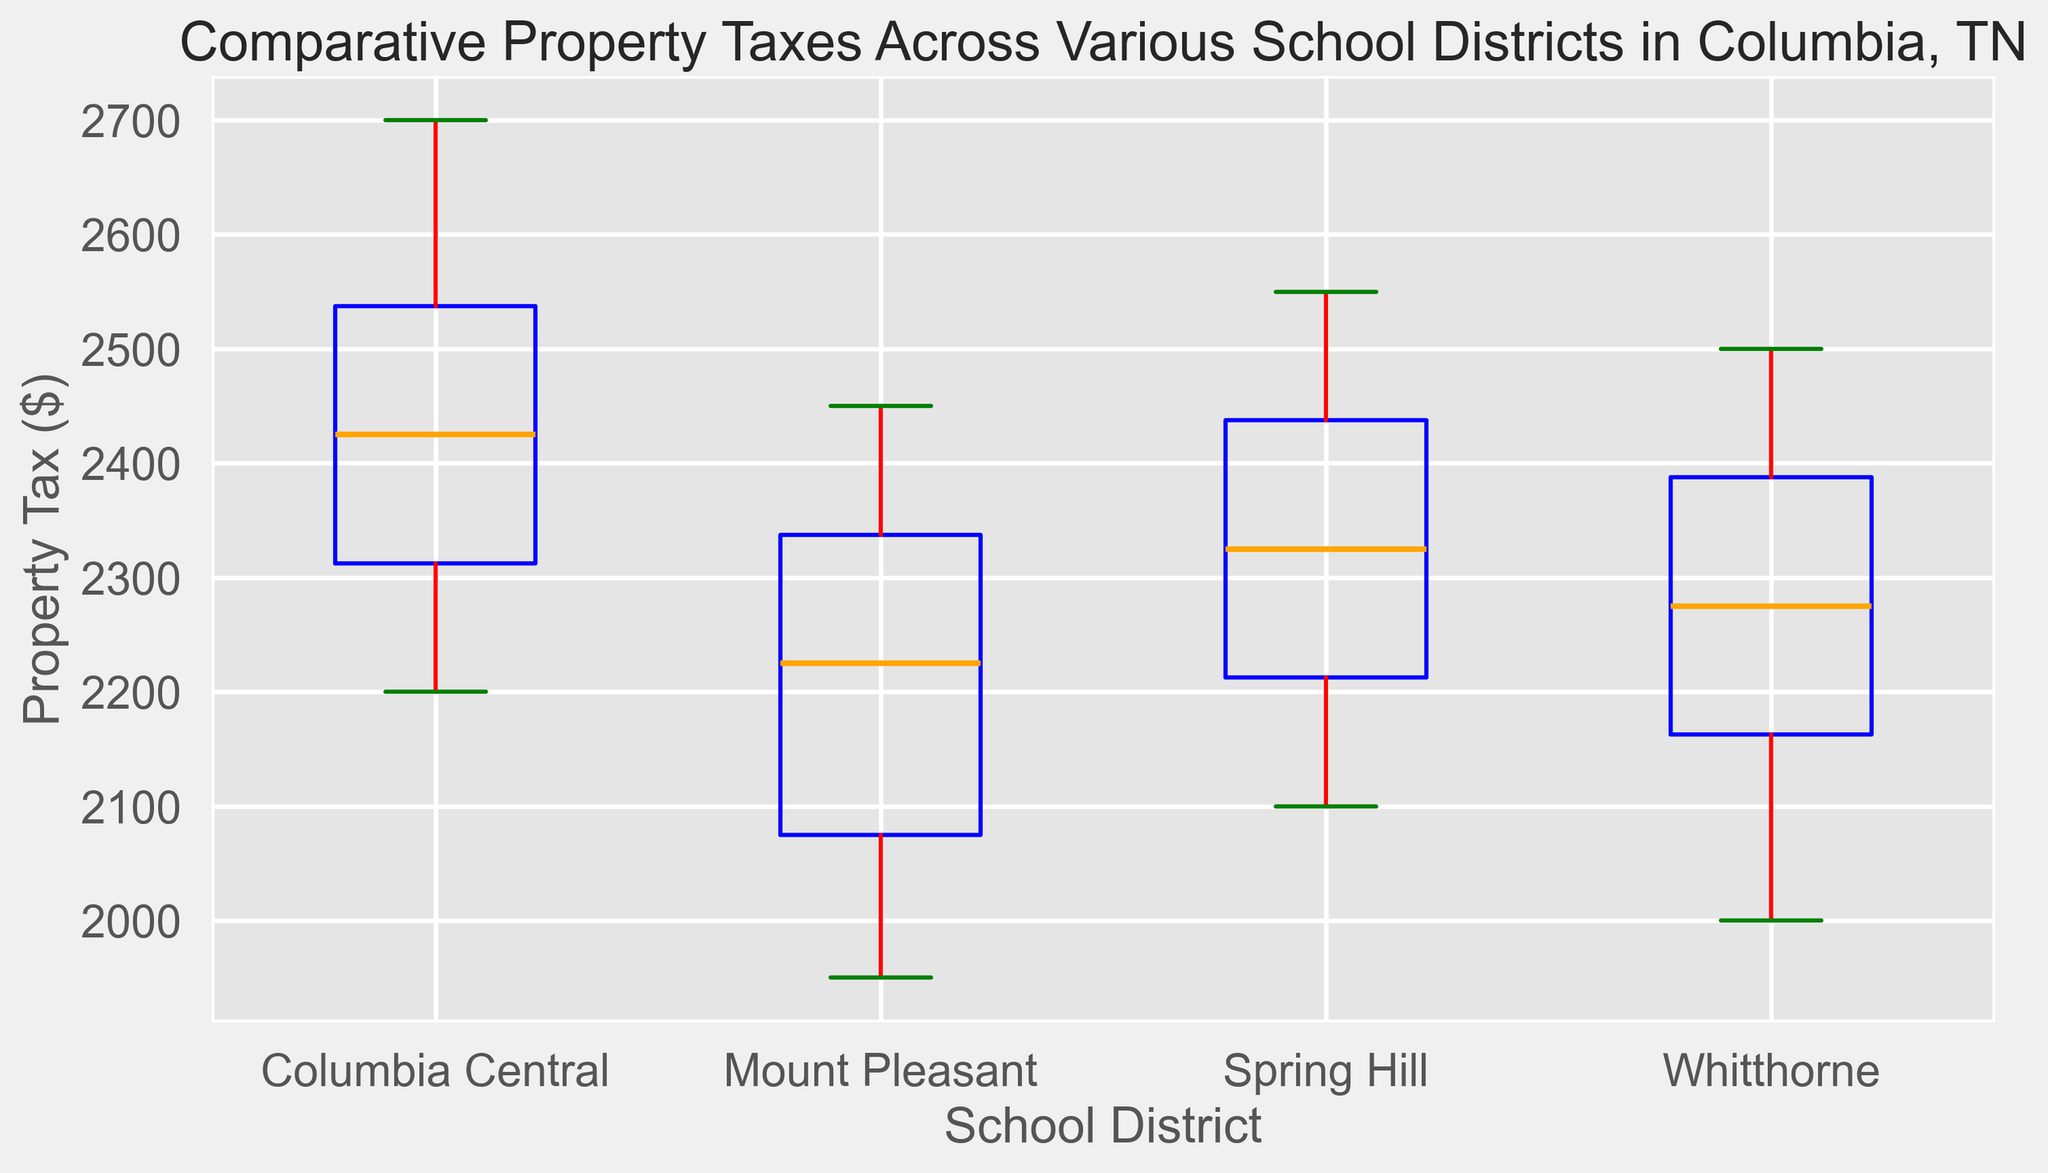Which school district has the highest median property tax? To find the school district with the highest median property tax, look at the median line inside the boxes for each district. Identify which median line is the highest.
Answer: Columbia Central Which district has the lowest upper whisker endpoint? The upper whisker endpoint is the top line extending from the boxes. Identify which district has the whisker with the lowest position.
Answer: Mount Pleasant What is the interquartile range (IQR) for Spring Hill? The IQR is calculated by subtracting the lower quartile (Q1) from the upper quartile (Q3). Identify these two values on the Spring Hill box plot and subtract Q1 from Q3.
Answer: 2500 - 2200 = 300 Which school district has the widest spread of property taxes? To determine the widest spread, look for the box plot with the greatest vertical distance from the lower whisker endpoint to the upper whisker endpoint.
Answer: Columbia Central How do the medians of Columbia Central and Whitthorne compare? Compare the median lines in the boxes for Columbia Central and Whitthorne to see which is higher.
Answer: Columbia Central's median is higher than Whitthorne's What is the range of property taxes for Mount Pleasant? The range is calculated by subtracting the minimum value (lower whisker endpoint) from the maximum value (upper whisker endpoint). Identify these values on the Mount Pleasant box plot and perform the subtraction.
Answer: 2450 - 1950 = 500 How do the variability of property taxes in Spring Hill and Mount Pleasant compare visually? Variability can be assessed by observing the length of the boxes and whiskers. The box and whiskers of Mount Pleasant are shorter compared to those of Spring Hill, indicating less variability.
Answer: Spring Hill has more variability than Mount Pleasant Which district has the most outliers? Outliers are indicated by individual points outside the whiskers. Count the number of outliers for each district.
Answer: Columbia Central What colors are used for the whiskers and box outlines in the plot? The whiskers are colored red, and the box outlines are colored blue, as indicated by the visual attributes in the plot.
Answer: Red (whiskers) and Blue (box outlines) What's the median property tax value for Whitthorne? Identify the position of the median line inside the Whitthorne box plot to determine the median property tax value.
Answer: 2250 